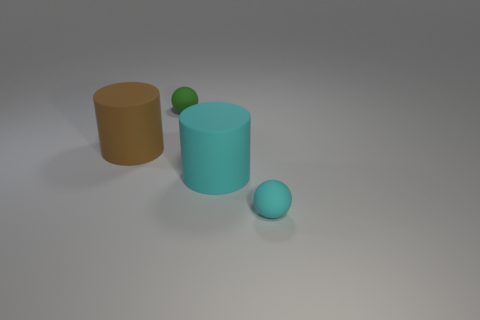There is a big cylinder in front of the brown object; what is its color?
Ensure brevity in your answer.  Cyan. There is a tiny thing that is on the left side of the cyan matte cylinder; is there a small cyan thing that is to the left of it?
Give a very brief answer. No. Is the number of brown matte spheres less than the number of big brown rubber objects?
Provide a short and direct response. Yes. There is a small object that is to the right of the rubber ball behind the large brown thing; what is its material?
Offer a very short reply. Rubber. Do the brown rubber object and the cyan matte ball have the same size?
Provide a succinct answer. No. What number of objects are either green matte balls or big matte cylinders?
Provide a short and direct response. 3. What is the size of the rubber thing that is both behind the small cyan ball and in front of the brown cylinder?
Your response must be concise. Large. Is the number of brown things behind the green matte thing less than the number of brown metallic objects?
Your answer should be very brief. No. What shape is the big cyan thing that is the same material as the green ball?
Give a very brief answer. Cylinder. Do the thing behind the large brown matte object and the small object that is in front of the brown thing have the same shape?
Keep it short and to the point. Yes. 